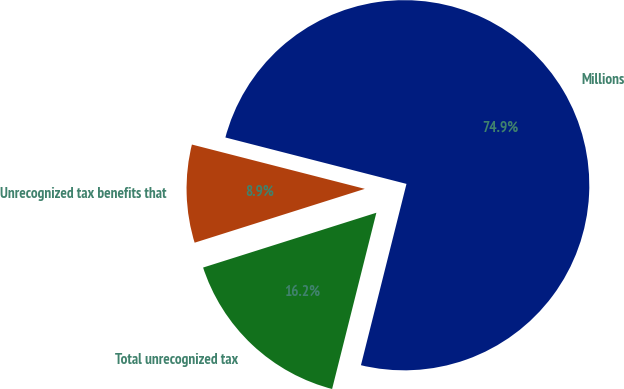Convert chart to OTSL. <chart><loc_0><loc_0><loc_500><loc_500><pie_chart><fcel>Millions<fcel>Unrecognized tax benefits that<fcel>Total unrecognized tax<nl><fcel>74.93%<fcel>8.87%<fcel>16.21%<nl></chart> 